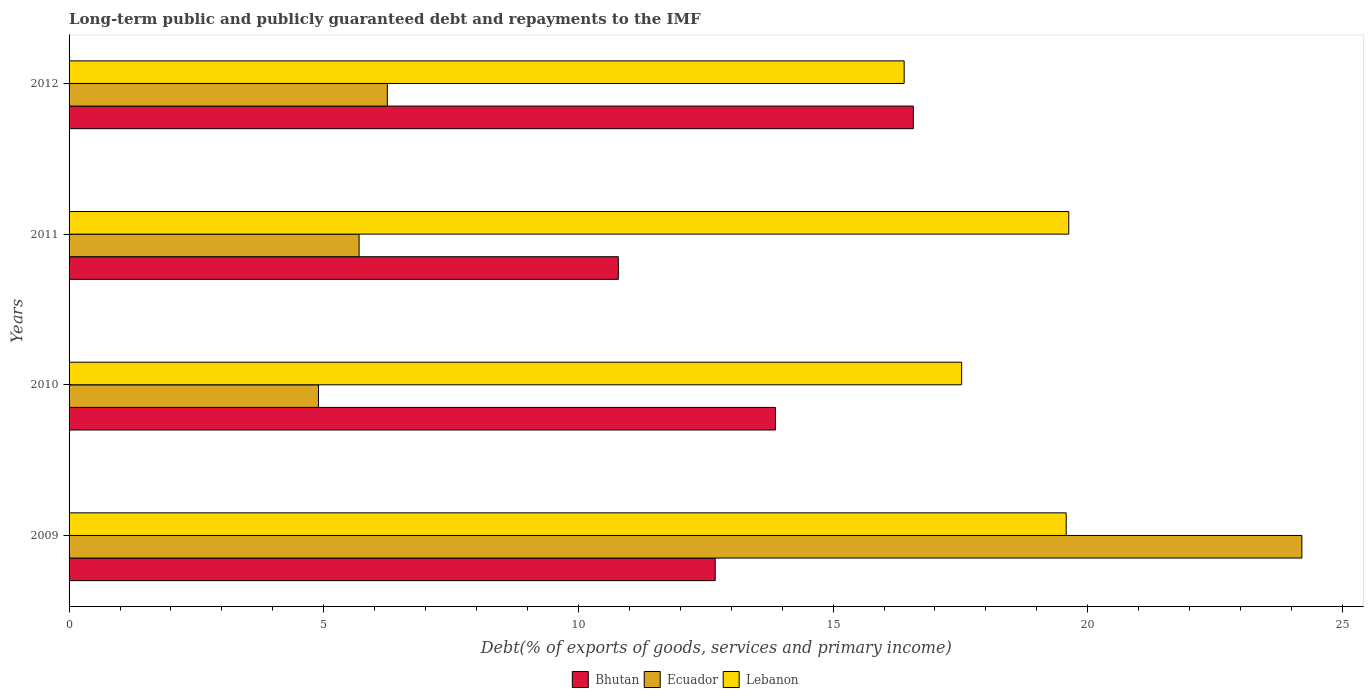How many different coloured bars are there?
Offer a terse response. 3. How many bars are there on the 4th tick from the bottom?
Provide a succinct answer. 3. What is the label of the 1st group of bars from the top?
Offer a very short reply. 2012. What is the debt and repayments in Ecuador in 2009?
Provide a short and direct response. 24.2. Across all years, what is the maximum debt and repayments in Lebanon?
Offer a terse response. 19.63. Across all years, what is the minimum debt and repayments in Bhutan?
Offer a very short reply. 10.78. In which year was the debt and repayments in Ecuador minimum?
Offer a terse response. 2010. What is the total debt and repayments in Lebanon in the graph?
Keep it short and to the point. 73.12. What is the difference between the debt and repayments in Ecuador in 2010 and that in 2012?
Provide a short and direct response. -1.35. What is the difference between the debt and repayments in Bhutan in 2010 and the debt and repayments in Lebanon in 2011?
Provide a succinct answer. -5.76. What is the average debt and repayments in Ecuador per year?
Your answer should be compact. 10.26. In the year 2010, what is the difference between the debt and repayments in Bhutan and debt and repayments in Lebanon?
Your response must be concise. -3.66. In how many years, is the debt and repayments in Ecuador greater than 1 %?
Your response must be concise. 4. What is the ratio of the debt and repayments in Lebanon in 2009 to that in 2012?
Give a very brief answer. 1.19. Is the difference between the debt and repayments in Bhutan in 2009 and 2010 greater than the difference between the debt and repayments in Lebanon in 2009 and 2010?
Offer a terse response. No. What is the difference between the highest and the second highest debt and repayments in Bhutan?
Ensure brevity in your answer.  2.71. What is the difference between the highest and the lowest debt and repayments in Bhutan?
Offer a very short reply. 5.79. What does the 2nd bar from the top in 2009 represents?
Your response must be concise. Ecuador. What does the 1st bar from the bottom in 2010 represents?
Provide a short and direct response. Bhutan. Is it the case that in every year, the sum of the debt and repayments in Bhutan and debt and repayments in Lebanon is greater than the debt and repayments in Ecuador?
Give a very brief answer. Yes. How many bars are there?
Offer a very short reply. 12. Are all the bars in the graph horizontal?
Provide a short and direct response. Yes. What is the difference between two consecutive major ticks on the X-axis?
Provide a succinct answer. 5. Are the values on the major ticks of X-axis written in scientific E-notation?
Make the answer very short. No. Does the graph contain any zero values?
Provide a short and direct response. No. Does the graph contain grids?
Keep it short and to the point. No. How are the legend labels stacked?
Offer a terse response. Horizontal. What is the title of the graph?
Keep it short and to the point. Long-term public and publicly guaranteed debt and repayments to the IMF. What is the label or title of the X-axis?
Ensure brevity in your answer.  Debt(% of exports of goods, services and primary income). What is the Debt(% of exports of goods, services and primary income) of Bhutan in 2009?
Make the answer very short. 12.68. What is the Debt(% of exports of goods, services and primary income) in Ecuador in 2009?
Give a very brief answer. 24.2. What is the Debt(% of exports of goods, services and primary income) of Lebanon in 2009?
Your answer should be very brief. 19.58. What is the Debt(% of exports of goods, services and primary income) of Bhutan in 2010?
Offer a very short reply. 13.87. What is the Debt(% of exports of goods, services and primary income) in Ecuador in 2010?
Offer a terse response. 4.9. What is the Debt(% of exports of goods, services and primary income) of Lebanon in 2010?
Ensure brevity in your answer.  17.52. What is the Debt(% of exports of goods, services and primary income) of Bhutan in 2011?
Your answer should be very brief. 10.78. What is the Debt(% of exports of goods, services and primary income) in Ecuador in 2011?
Give a very brief answer. 5.69. What is the Debt(% of exports of goods, services and primary income) in Lebanon in 2011?
Make the answer very short. 19.63. What is the Debt(% of exports of goods, services and primary income) in Bhutan in 2012?
Ensure brevity in your answer.  16.58. What is the Debt(% of exports of goods, services and primary income) in Ecuador in 2012?
Provide a succinct answer. 6.25. What is the Debt(% of exports of goods, services and primary income) in Lebanon in 2012?
Give a very brief answer. 16.39. Across all years, what is the maximum Debt(% of exports of goods, services and primary income) in Bhutan?
Your answer should be very brief. 16.58. Across all years, what is the maximum Debt(% of exports of goods, services and primary income) in Ecuador?
Keep it short and to the point. 24.2. Across all years, what is the maximum Debt(% of exports of goods, services and primary income) of Lebanon?
Your response must be concise. 19.63. Across all years, what is the minimum Debt(% of exports of goods, services and primary income) of Bhutan?
Provide a succinct answer. 10.78. Across all years, what is the minimum Debt(% of exports of goods, services and primary income) of Ecuador?
Provide a succinct answer. 4.9. Across all years, what is the minimum Debt(% of exports of goods, services and primary income) in Lebanon?
Provide a short and direct response. 16.39. What is the total Debt(% of exports of goods, services and primary income) in Bhutan in the graph?
Provide a succinct answer. 53.91. What is the total Debt(% of exports of goods, services and primary income) in Ecuador in the graph?
Offer a very short reply. 41.04. What is the total Debt(% of exports of goods, services and primary income) of Lebanon in the graph?
Provide a succinct answer. 73.12. What is the difference between the Debt(% of exports of goods, services and primary income) in Bhutan in 2009 and that in 2010?
Provide a short and direct response. -1.18. What is the difference between the Debt(% of exports of goods, services and primary income) in Ecuador in 2009 and that in 2010?
Provide a short and direct response. 19.31. What is the difference between the Debt(% of exports of goods, services and primary income) in Lebanon in 2009 and that in 2010?
Ensure brevity in your answer.  2.05. What is the difference between the Debt(% of exports of goods, services and primary income) of Bhutan in 2009 and that in 2011?
Keep it short and to the point. 1.9. What is the difference between the Debt(% of exports of goods, services and primary income) of Ecuador in 2009 and that in 2011?
Ensure brevity in your answer.  18.51. What is the difference between the Debt(% of exports of goods, services and primary income) in Lebanon in 2009 and that in 2011?
Your answer should be compact. -0.05. What is the difference between the Debt(% of exports of goods, services and primary income) of Bhutan in 2009 and that in 2012?
Your response must be concise. -3.89. What is the difference between the Debt(% of exports of goods, services and primary income) in Ecuador in 2009 and that in 2012?
Make the answer very short. 17.95. What is the difference between the Debt(% of exports of goods, services and primary income) of Lebanon in 2009 and that in 2012?
Offer a terse response. 3.18. What is the difference between the Debt(% of exports of goods, services and primary income) in Bhutan in 2010 and that in 2011?
Make the answer very short. 3.08. What is the difference between the Debt(% of exports of goods, services and primary income) in Ecuador in 2010 and that in 2011?
Give a very brief answer. -0.8. What is the difference between the Debt(% of exports of goods, services and primary income) in Lebanon in 2010 and that in 2011?
Give a very brief answer. -2.1. What is the difference between the Debt(% of exports of goods, services and primary income) in Bhutan in 2010 and that in 2012?
Your response must be concise. -2.71. What is the difference between the Debt(% of exports of goods, services and primary income) in Ecuador in 2010 and that in 2012?
Your answer should be compact. -1.35. What is the difference between the Debt(% of exports of goods, services and primary income) in Lebanon in 2010 and that in 2012?
Offer a terse response. 1.13. What is the difference between the Debt(% of exports of goods, services and primary income) in Bhutan in 2011 and that in 2012?
Your answer should be compact. -5.79. What is the difference between the Debt(% of exports of goods, services and primary income) in Ecuador in 2011 and that in 2012?
Make the answer very short. -0.55. What is the difference between the Debt(% of exports of goods, services and primary income) in Lebanon in 2011 and that in 2012?
Provide a succinct answer. 3.23. What is the difference between the Debt(% of exports of goods, services and primary income) in Bhutan in 2009 and the Debt(% of exports of goods, services and primary income) in Ecuador in 2010?
Ensure brevity in your answer.  7.79. What is the difference between the Debt(% of exports of goods, services and primary income) of Bhutan in 2009 and the Debt(% of exports of goods, services and primary income) of Lebanon in 2010?
Your answer should be compact. -4.84. What is the difference between the Debt(% of exports of goods, services and primary income) of Ecuador in 2009 and the Debt(% of exports of goods, services and primary income) of Lebanon in 2010?
Your answer should be very brief. 6.68. What is the difference between the Debt(% of exports of goods, services and primary income) in Bhutan in 2009 and the Debt(% of exports of goods, services and primary income) in Ecuador in 2011?
Your response must be concise. 6.99. What is the difference between the Debt(% of exports of goods, services and primary income) in Bhutan in 2009 and the Debt(% of exports of goods, services and primary income) in Lebanon in 2011?
Give a very brief answer. -6.94. What is the difference between the Debt(% of exports of goods, services and primary income) in Ecuador in 2009 and the Debt(% of exports of goods, services and primary income) in Lebanon in 2011?
Your answer should be very brief. 4.58. What is the difference between the Debt(% of exports of goods, services and primary income) in Bhutan in 2009 and the Debt(% of exports of goods, services and primary income) in Ecuador in 2012?
Offer a very short reply. 6.44. What is the difference between the Debt(% of exports of goods, services and primary income) of Bhutan in 2009 and the Debt(% of exports of goods, services and primary income) of Lebanon in 2012?
Make the answer very short. -3.71. What is the difference between the Debt(% of exports of goods, services and primary income) in Ecuador in 2009 and the Debt(% of exports of goods, services and primary income) in Lebanon in 2012?
Your response must be concise. 7.81. What is the difference between the Debt(% of exports of goods, services and primary income) of Bhutan in 2010 and the Debt(% of exports of goods, services and primary income) of Ecuador in 2011?
Provide a short and direct response. 8.17. What is the difference between the Debt(% of exports of goods, services and primary income) in Bhutan in 2010 and the Debt(% of exports of goods, services and primary income) in Lebanon in 2011?
Keep it short and to the point. -5.76. What is the difference between the Debt(% of exports of goods, services and primary income) of Ecuador in 2010 and the Debt(% of exports of goods, services and primary income) of Lebanon in 2011?
Your response must be concise. -14.73. What is the difference between the Debt(% of exports of goods, services and primary income) in Bhutan in 2010 and the Debt(% of exports of goods, services and primary income) in Ecuador in 2012?
Give a very brief answer. 7.62. What is the difference between the Debt(% of exports of goods, services and primary income) in Bhutan in 2010 and the Debt(% of exports of goods, services and primary income) in Lebanon in 2012?
Your answer should be compact. -2.53. What is the difference between the Debt(% of exports of goods, services and primary income) in Ecuador in 2010 and the Debt(% of exports of goods, services and primary income) in Lebanon in 2012?
Provide a short and direct response. -11.5. What is the difference between the Debt(% of exports of goods, services and primary income) in Bhutan in 2011 and the Debt(% of exports of goods, services and primary income) in Ecuador in 2012?
Keep it short and to the point. 4.54. What is the difference between the Debt(% of exports of goods, services and primary income) in Bhutan in 2011 and the Debt(% of exports of goods, services and primary income) in Lebanon in 2012?
Provide a succinct answer. -5.61. What is the difference between the Debt(% of exports of goods, services and primary income) in Ecuador in 2011 and the Debt(% of exports of goods, services and primary income) in Lebanon in 2012?
Provide a short and direct response. -10.7. What is the average Debt(% of exports of goods, services and primary income) in Bhutan per year?
Make the answer very short. 13.48. What is the average Debt(% of exports of goods, services and primary income) in Ecuador per year?
Keep it short and to the point. 10.26. What is the average Debt(% of exports of goods, services and primary income) in Lebanon per year?
Your answer should be very brief. 18.28. In the year 2009, what is the difference between the Debt(% of exports of goods, services and primary income) in Bhutan and Debt(% of exports of goods, services and primary income) in Ecuador?
Offer a very short reply. -11.52. In the year 2009, what is the difference between the Debt(% of exports of goods, services and primary income) in Bhutan and Debt(% of exports of goods, services and primary income) in Lebanon?
Offer a terse response. -6.89. In the year 2009, what is the difference between the Debt(% of exports of goods, services and primary income) of Ecuador and Debt(% of exports of goods, services and primary income) of Lebanon?
Keep it short and to the point. 4.63. In the year 2010, what is the difference between the Debt(% of exports of goods, services and primary income) in Bhutan and Debt(% of exports of goods, services and primary income) in Ecuador?
Keep it short and to the point. 8.97. In the year 2010, what is the difference between the Debt(% of exports of goods, services and primary income) of Bhutan and Debt(% of exports of goods, services and primary income) of Lebanon?
Make the answer very short. -3.66. In the year 2010, what is the difference between the Debt(% of exports of goods, services and primary income) of Ecuador and Debt(% of exports of goods, services and primary income) of Lebanon?
Your response must be concise. -12.63. In the year 2011, what is the difference between the Debt(% of exports of goods, services and primary income) of Bhutan and Debt(% of exports of goods, services and primary income) of Ecuador?
Offer a terse response. 5.09. In the year 2011, what is the difference between the Debt(% of exports of goods, services and primary income) in Bhutan and Debt(% of exports of goods, services and primary income) in Lebanon?
Offer a very short reply. -8.84. In the year 2011, what is the difference between the Debt(% of exports of goods, services and primary income) in Ecuador and Debt(% of exports of goods, services and primary income) in Lebanon?
Keep it short and to the point. -13.93. In the year 2012, what is the difference between the Debt(% of exports of goods, services and primary income) in Bhutan and Debt(% of exports of goods, services and primary income) in Ecuador?
Offer a terse response. 10.33. In the year 2012, what is the difference between the Debt(% of exports of goods, services and primary income) of Bhutan and Debt(% of exports of goods, services and primary income) of Lebanon?
Your response must be concise. 0.18. In the year 2012, what is the difference between the Debt(% of exports of goods, services and primary income) of Ecuador and Debt(% of exports of goods, services and primary income) of Lebanon?
Give a very brief answer. -10.15. What is the ratio of the Debt(% of exports of goods, services and primary income) in Bhutan in 2009 to that in 2010?
Your answer should be compact. 0.91. What is the ratio of the Debt(% of exports of goods, services and primary income) of Ecuador in 2009 to that in 2010?
Your response must be concise. 4.94. What is the ratio of the Debt(% of exports of goods, services and primary income) in Lebanon in 2009 to that in 2010?
Provide a short and direct response. 1.12. What is the ratio of the Debt(% of exports of goods, services and primary income) in Bhutan in 2009 to that in 2011?
Your answer should be very brief. 1.18. What is the ratio of the Debt(% of exports of goods, services and primary income) of Ecuador in 2009 to that in 2011?
Your answer should be very brief. 4.25. What is the ratio of the Debt(% of exports of goods, services and primary income) of Bhutan in 2009 to that in 2012?
Your answer should be very brief. 0.77. What is the ratio of the Debt(% of exports of goods, services and primary income) of Ecuador in 2009 to that in 2012?
Make the answer very short. 3.87. What is the ratio of the Debt(% of exports of goods, services and primary income) of Lebanon in 2009 to that in 2012?
Your answer should be compact. 1.19. What is the ratio of the Debt(% of exports of goods, services and primary income) in Bhutan in 2010 to that in 2011?
Provide a short and direct response. 1.29. What is the ratio of the Debt(% of exports of goods, services and primary income) in Ecuador in 2010 to that in 2011?
Your answer should be very brief. 0.86. What is the ratio of the Debt(% of exports of goods, services and primary income) in Lebanon in 2010 to that in 2011?
Keep it short and to the point. 0.89. What is the ratio of the Debt(% of exports of goods, services and primary income) in Bhutan in 2010 to that in 2012?
Your answer should be very brief. 0.84. What is the ratio of the Debt(% of exports of goods, services and primary income) in Ecuador in 2010 to that in 2012?
Your response must be concise. 0.78. What is the ratio of the Debt(% of exports of goods, services and primary income) of Lebanon in 2010 to that in 2012?
Your answer should be compact. 1.07. What is the ratio of the Debt(% of exports of goods, services and primary income) of Bhutan in 2011 to that in 2012?
Your answer should be very brief. 0.65. What is the ratio of the Debt(% of exports of goods, services and primary income) of Ecuador in 2011 to that in 2012?
Your response must be concise. 0.91. What is the ratio of the Debt(% of exports of goods, services and primary income) in Lebanon in 2011 to that in 2012?
Keep it short and to the point. 1.2. What is the difference between the highest and the second highest Debt(% of exports of goods, services and primary income) in Bhutan?
Offer a terse response. 2.71. What is the difference between the highest and the second highest Debt(% of exports of goods, services and primary income) of Ecuador?
Give a very brief answer. 17.95. What is the difference between the highest and the second highest Debt(% of exports of goods, services and primary income) of Lebanon?
Provide a succinct answer. 0.05. What is the difference between the highest and the lowest Debt(% of exports of goods, services and primary income) of Bhutan?
Your answer should be compact. 5.79. What is the difference between the highest and the lowest Debt(% of exports of goods, services and primary income) of Ecuador?
Your response must be concise. 19.31. What is the difference between the highest and the lowest Debt(% of exports of goods, services and primary income) in Lebanon?
Offer a very short reply. 3.23. 